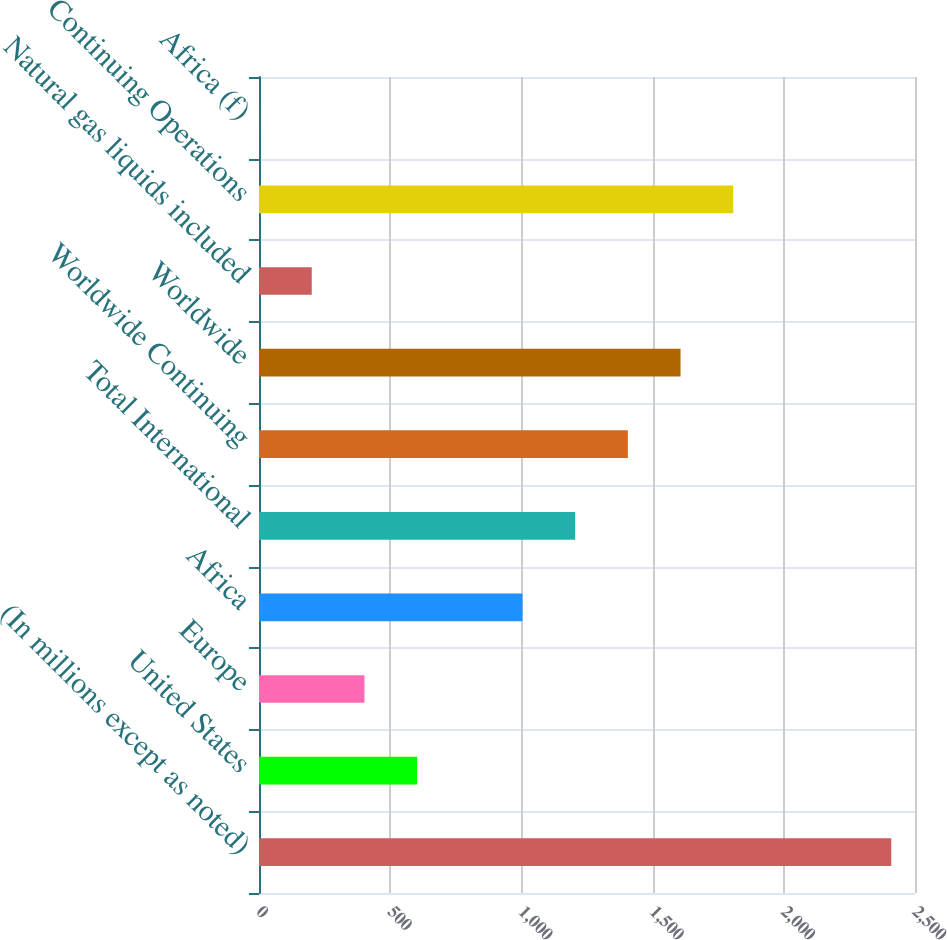<chart> <loc_0><loc_0><loc_500><loc_500><bar_chart><fcel>(In millions except as noted)<fcel>United States<fcel>Europe<fcel>Africa<fcel>Total International<fcel>Worldwide Continuing<fcel>Worldwide<fcel>Natural gas liquids included<fcel>Continuing Operations<fcel>Africa (f)<nl><fcel>2409.58<fcel>602.59<fcel>401.81<fcel>1004.14<fcel>1204.91<fcel>1405.69<fcel>1606.47<fcel>201.03<fcel>1807.25<fcel>0.25<nl></chart> 